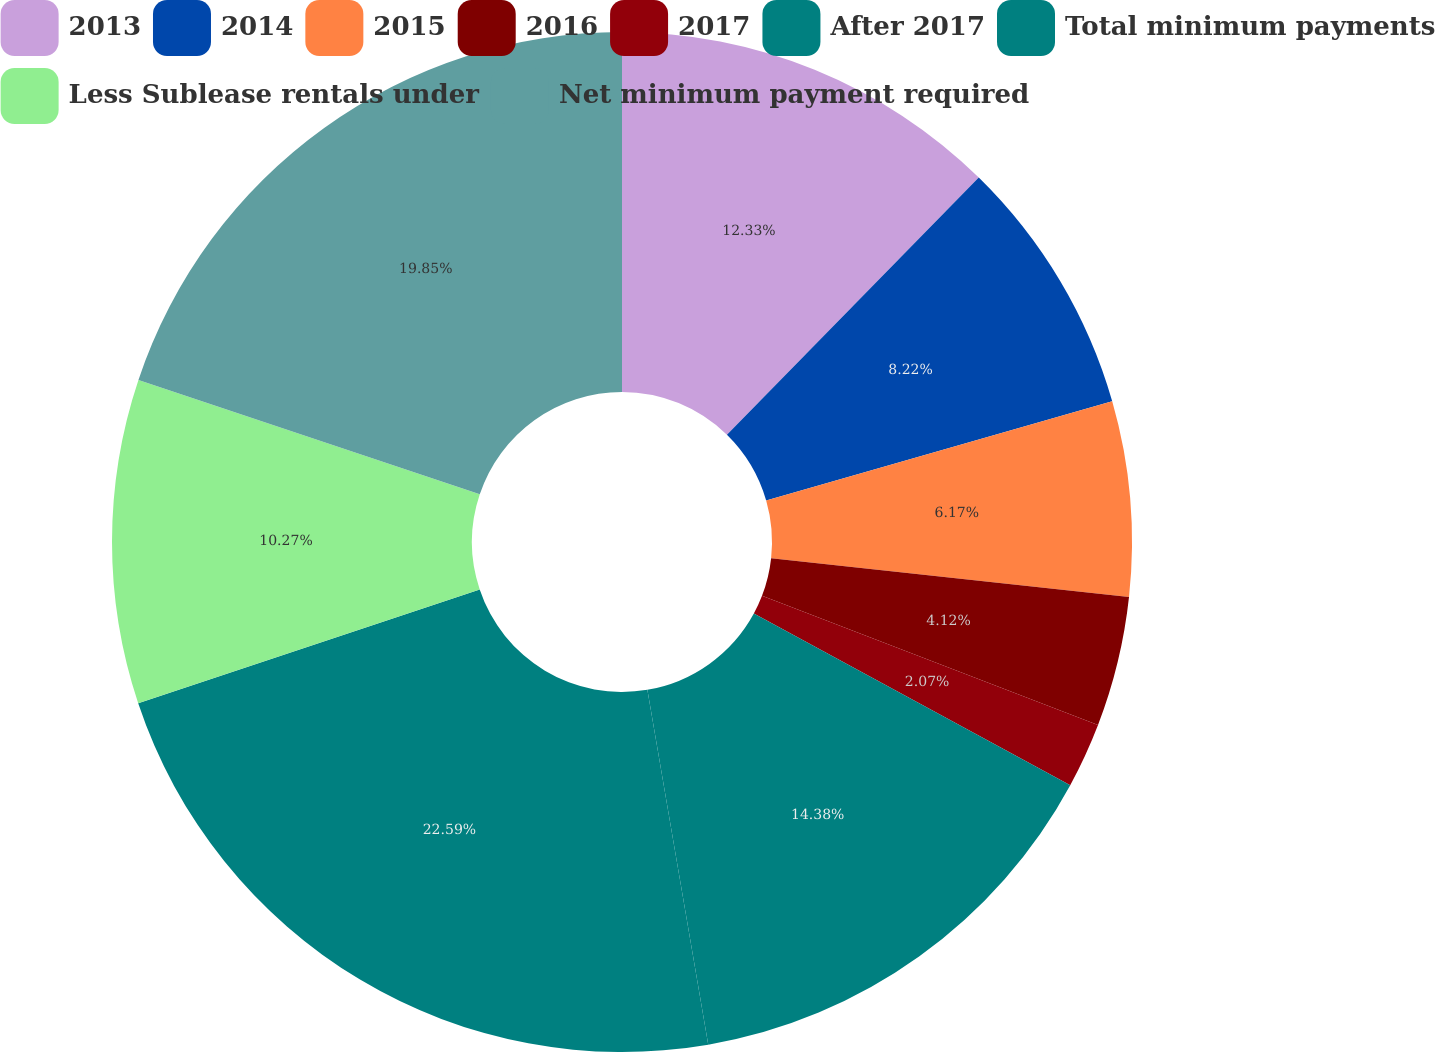Convert chart to OTSL. <chart><loc_0><loc_0><loc_500><loc_500><pie_chart><fcel>2013<fcel>2014<fcel>2015<fcel>2016<fcel>2017<fcel>After 2017<fcel>Total minimum payments<fcel>Less Sublease rentals under<fcel>Net minimum payment required<nl><fcel>12.33%<fcel>8.22%<fcel>6.17%<fcel>4.12%<fcel>2.07%<fcel>14.38%<fcel>22.58%<fcel>10.27%<fcel>19.85%<nl></chart> 